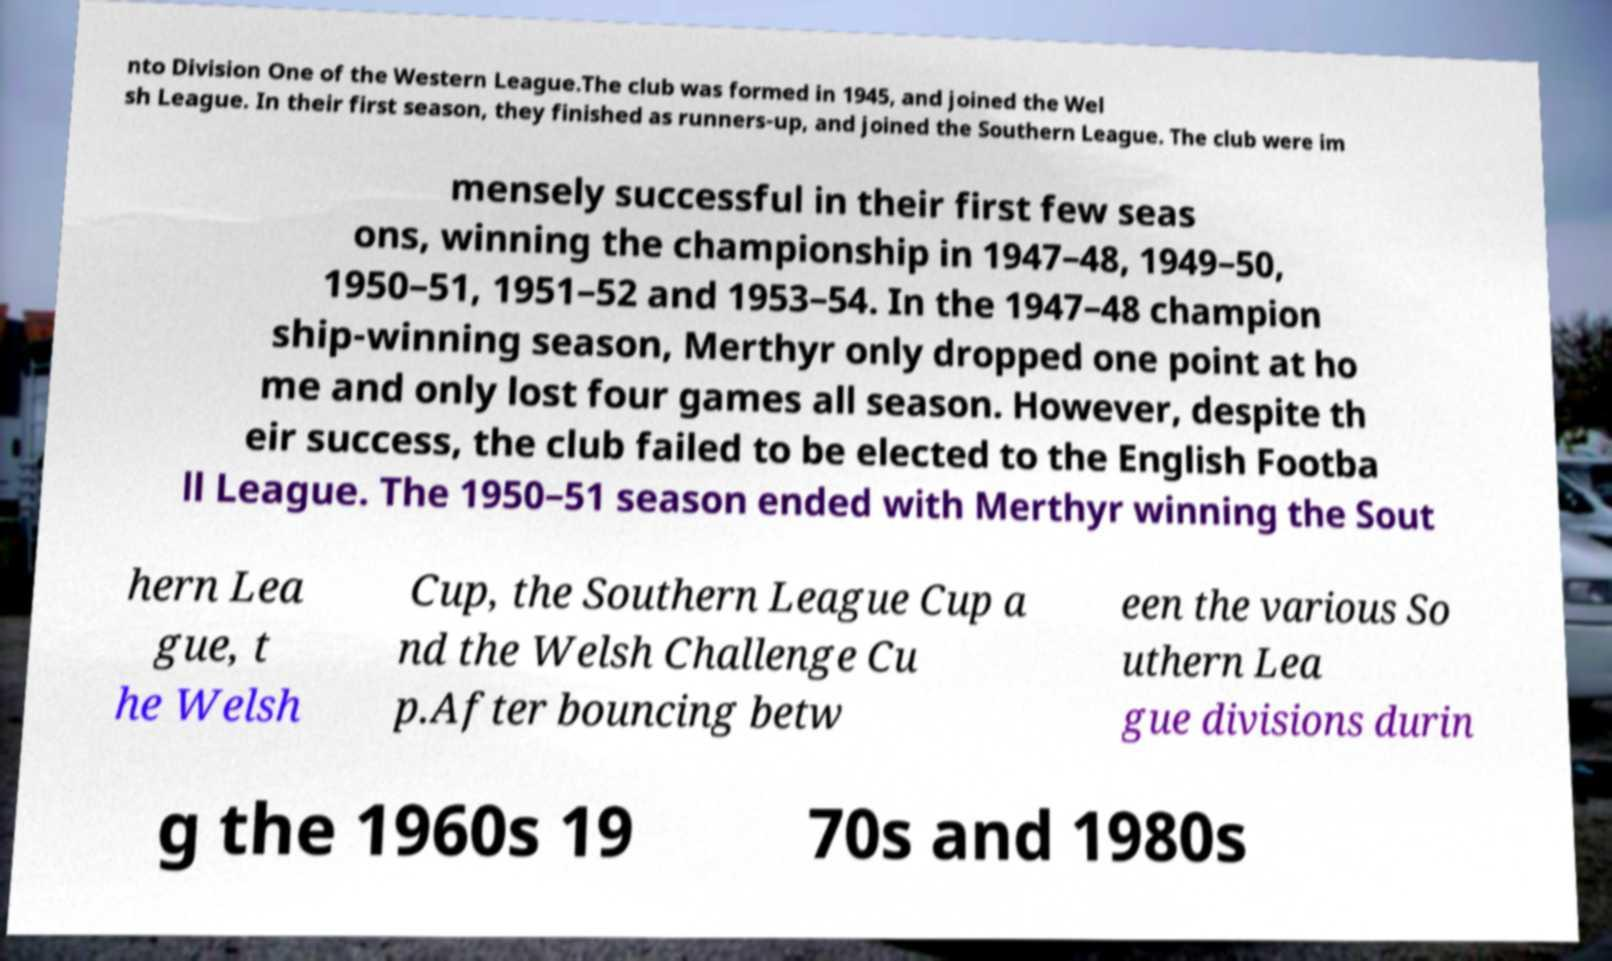Please identify and transcribe the text found in this image. nto Division One of the Western League.The club was formed in 1945, and joined the Wel sh League. In their first season, they finished as runners-up, and joined the Southern League. The club were im mensely successful in their first few seas ons, winning the championship in 1947–48, 1949–50, 1950–51, 1951–52 and 1953–54. In the 1947–48 champion ship-winning season, Merthyr only dropped one point at ho me and only lost four games all season. However, despite th eir success, the club failed to be elected to the English Footba ll League. The 1950–51 season ended with Merthyr winning the Sout hern Lea gue, t he Welsh Cup, the Southern League Cup a nd the Welsh Challenge Cu p.After bouncing betw een the various So uthern Lea gue divisions durin g the 1960s 19 70s and 1980s 